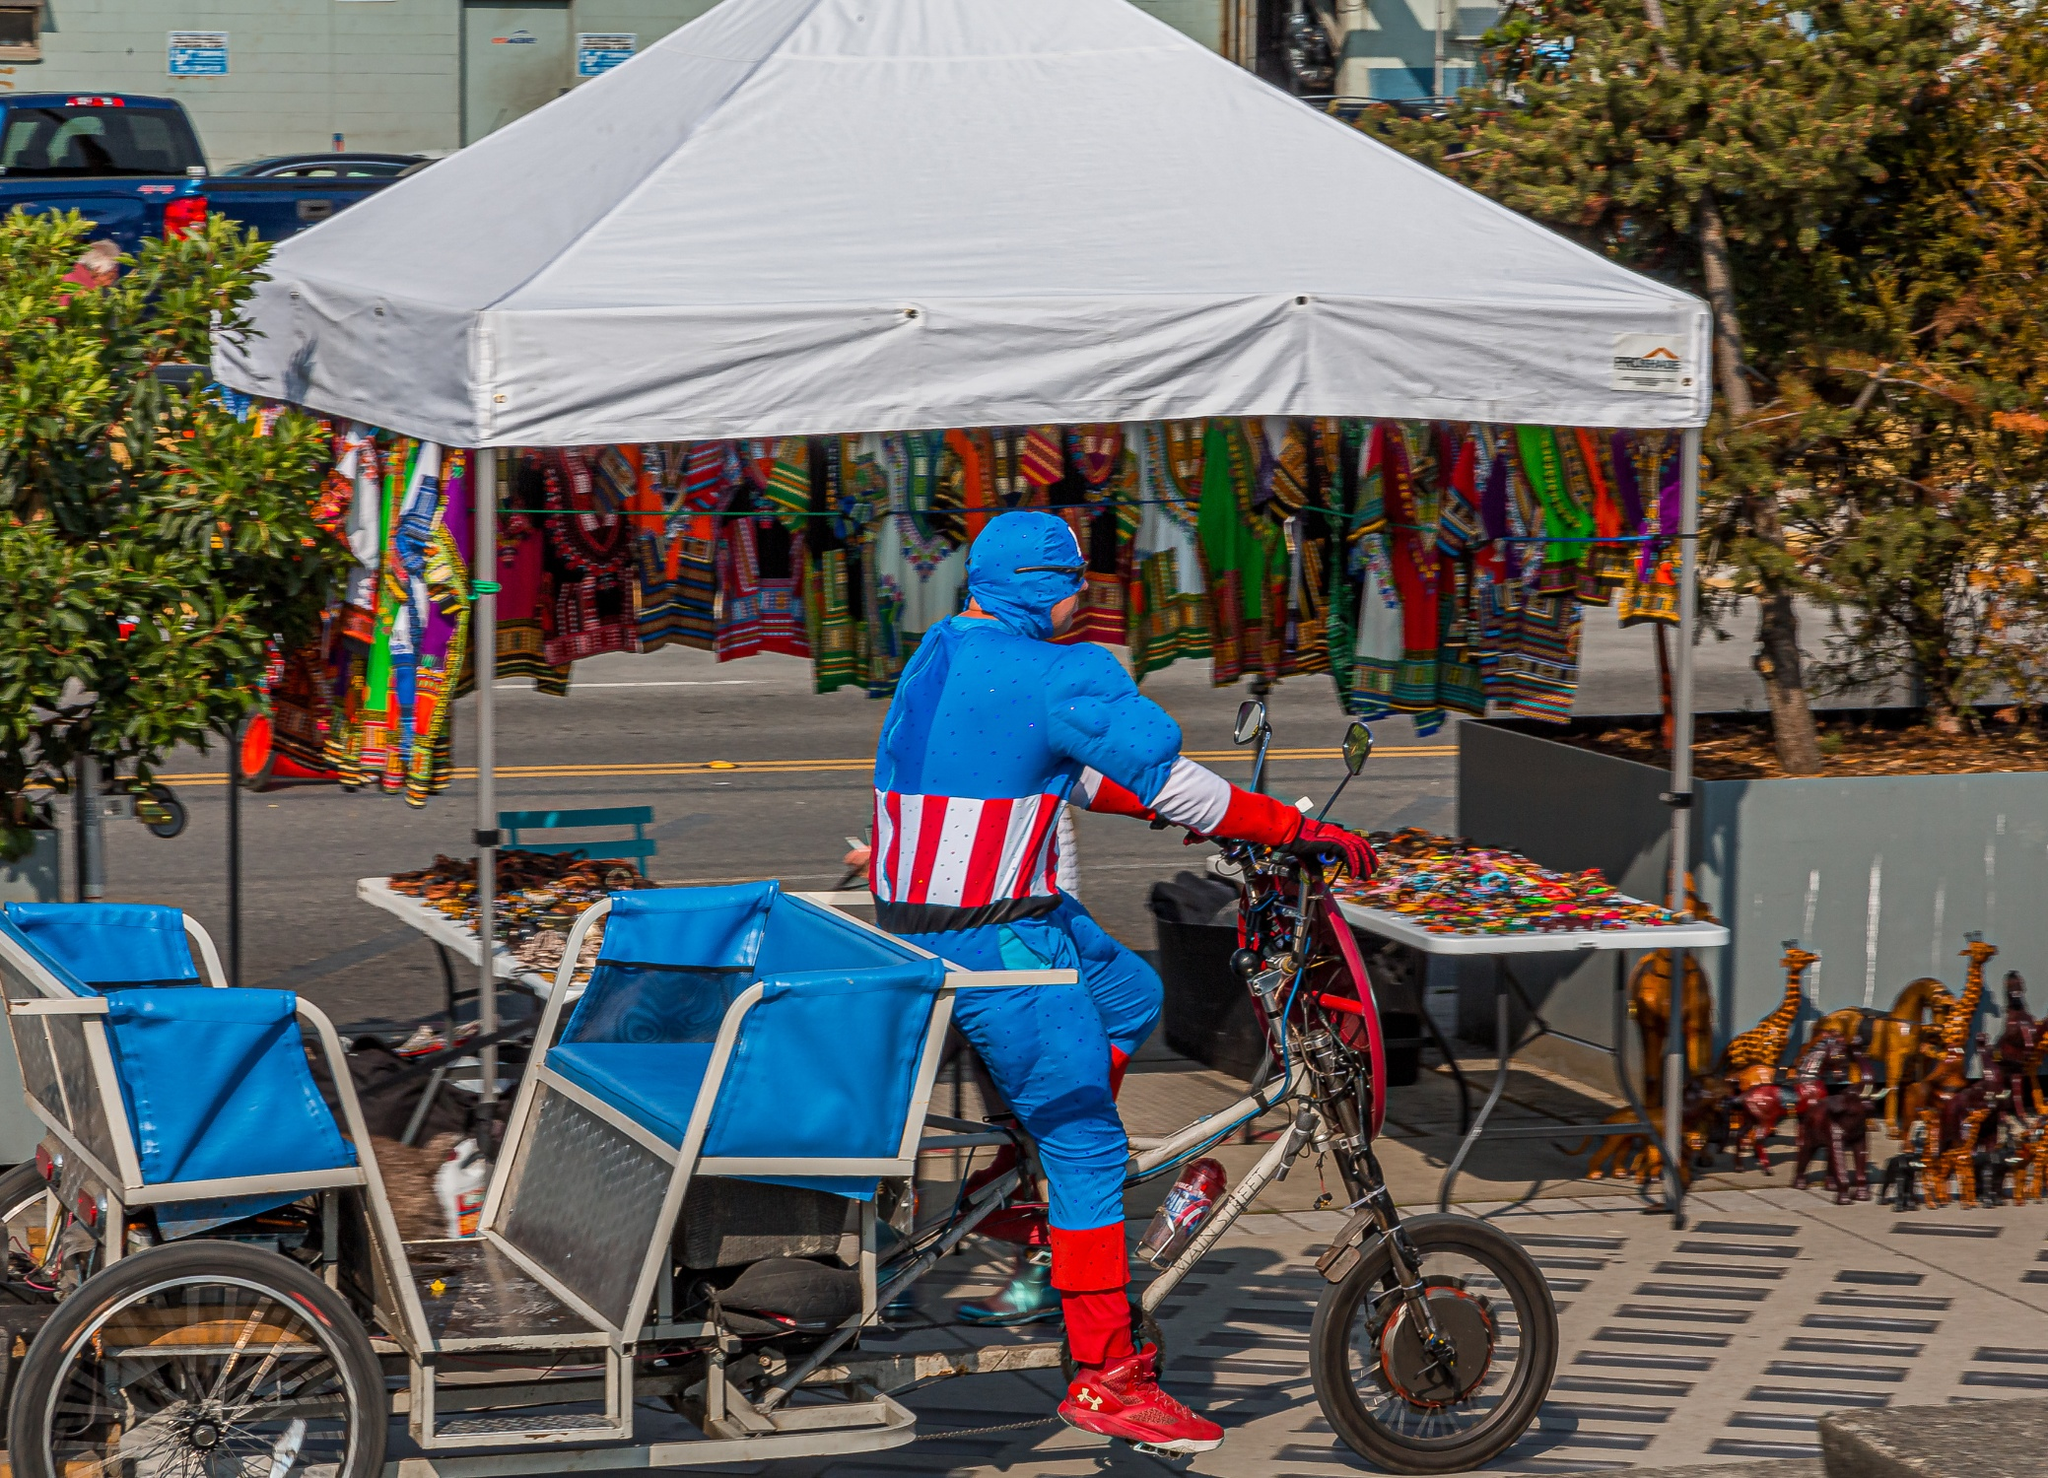Can you describe the energy or vibe of the location shown in the photo? The location in the photo exudes a dynamic and bustling vibe, characteristic of an urban market or street festival. The combination of diverse stalls selling colorful items, the movement of the cyclist in a striking costume, and the visible greenery provides a lively, eclectic feel. It reflects the vibrancy of city life where commerce, culture, and creativity intersect, likely making it a hub of activity that attracts various individuals interested in the unique offerings and energetic atmosphere. 